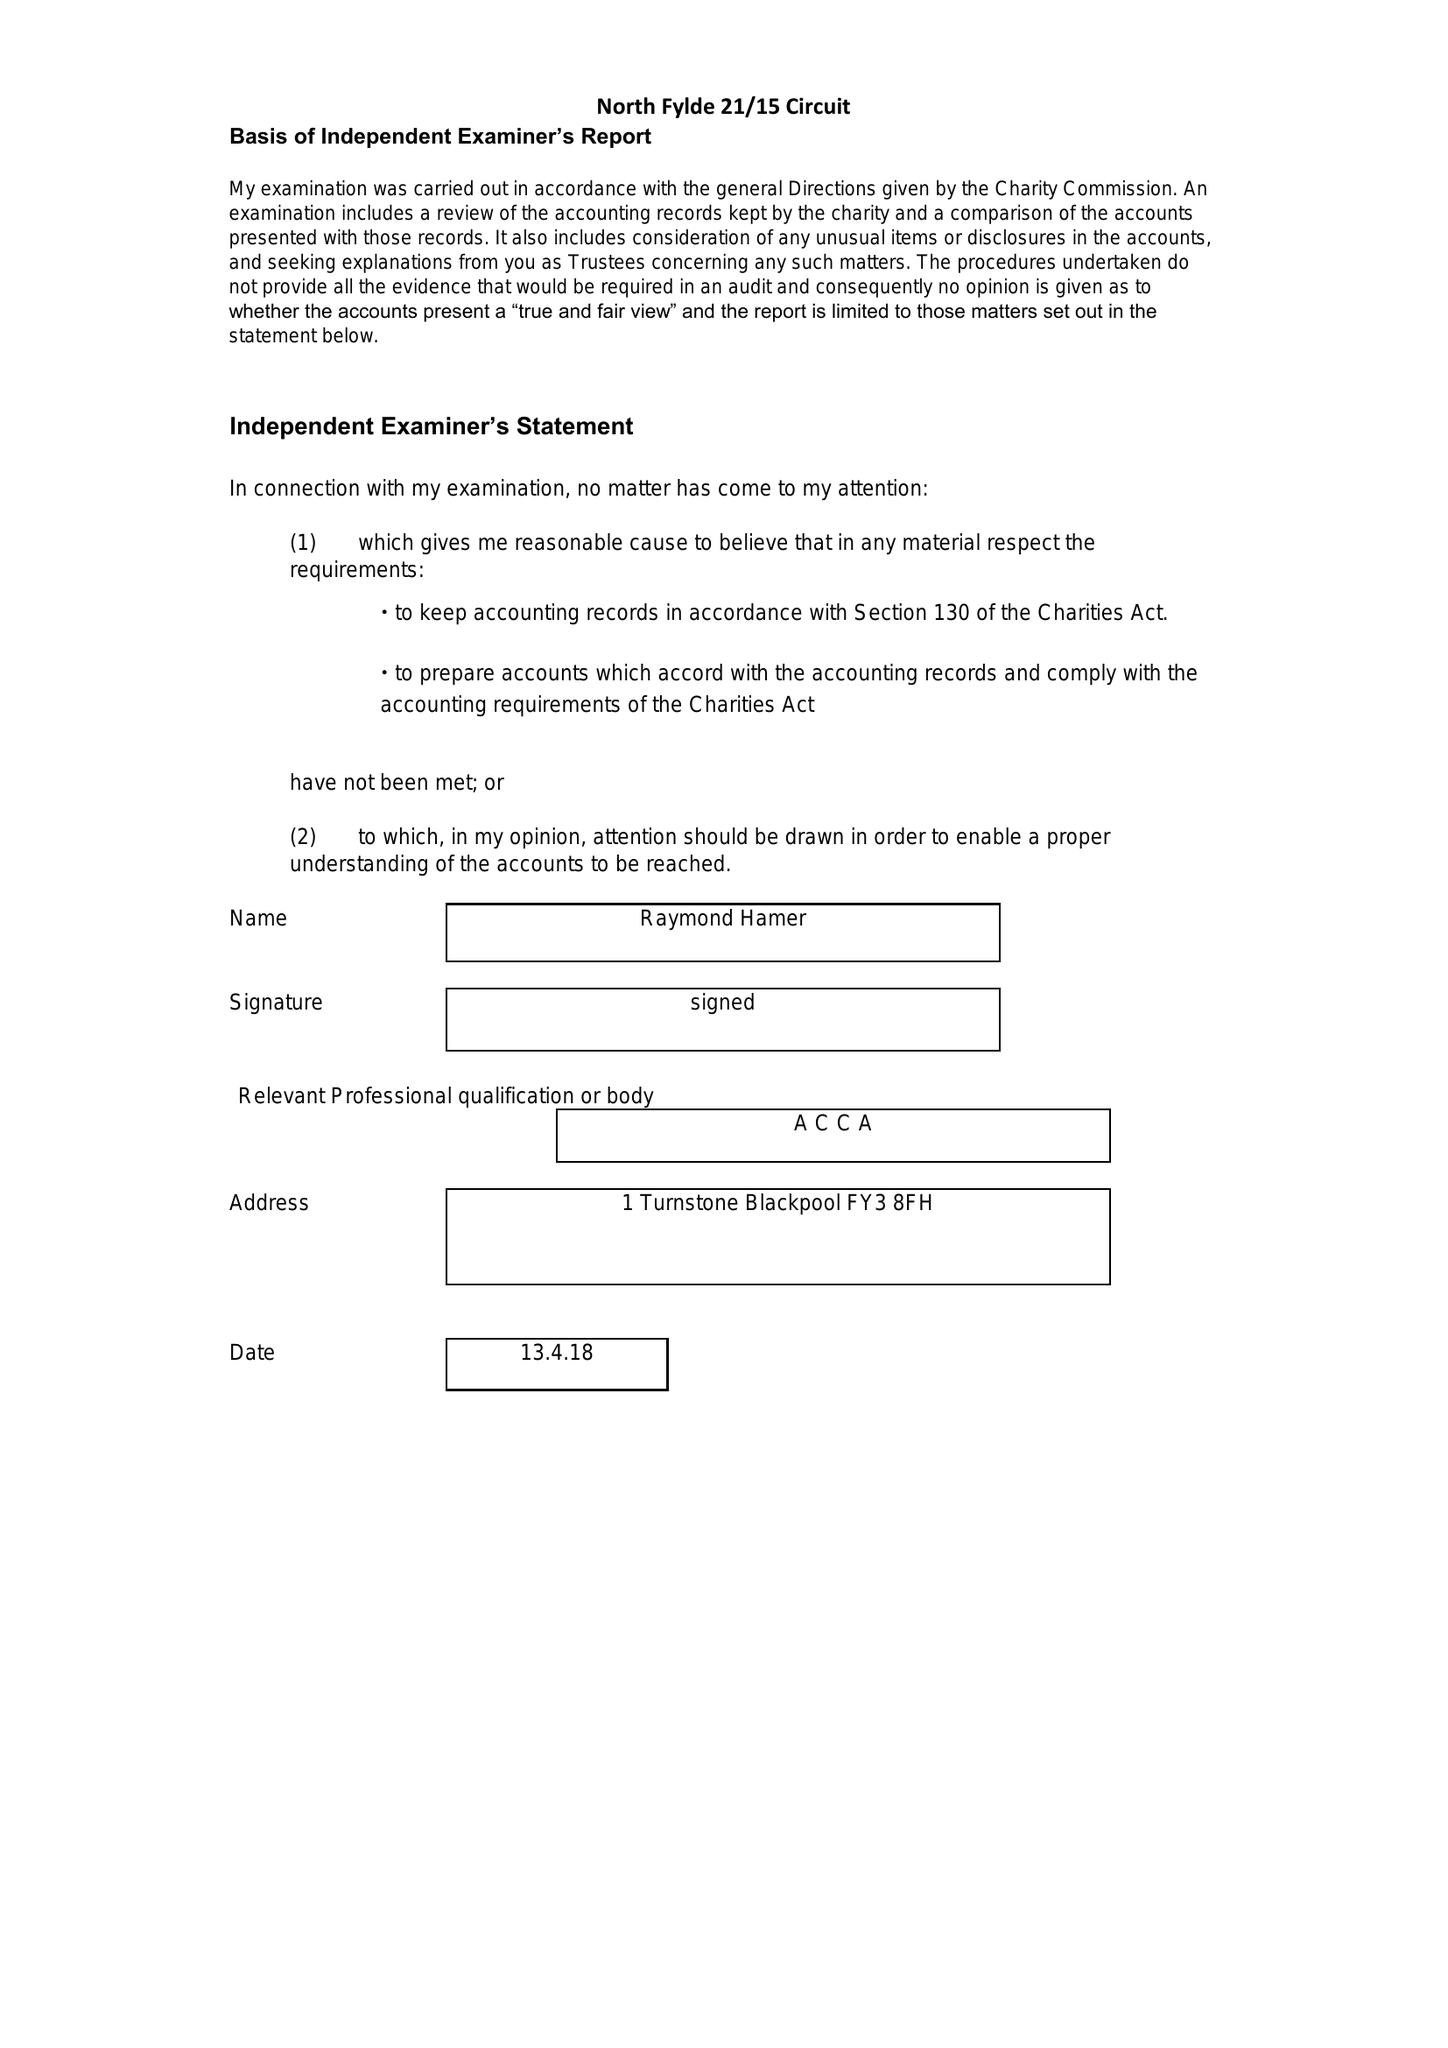What is the value for the income_annually_in_british_pounds?
Answer the question using a single word or phrase. 278722.00 